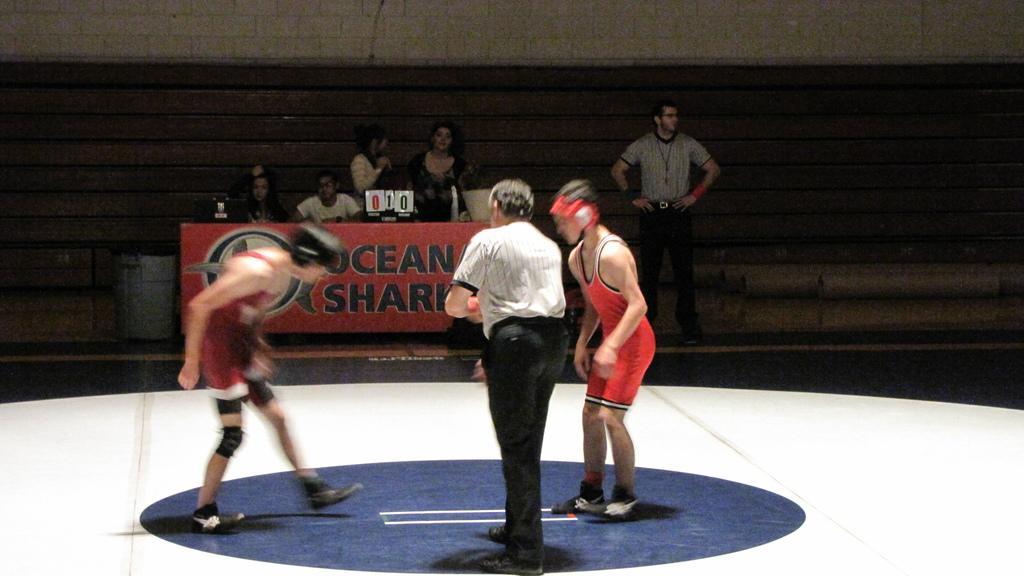In one or two sentences, can you explain what this image depicts? This looks like a wrestling stage. I can see two wrestlers standing. This is the table with a hoarding. I can see two people sitting and few people standing. This looks like a dustbin. I think this is the wooden wall. I can see a laptop, scoreboard and few other things on the table. 